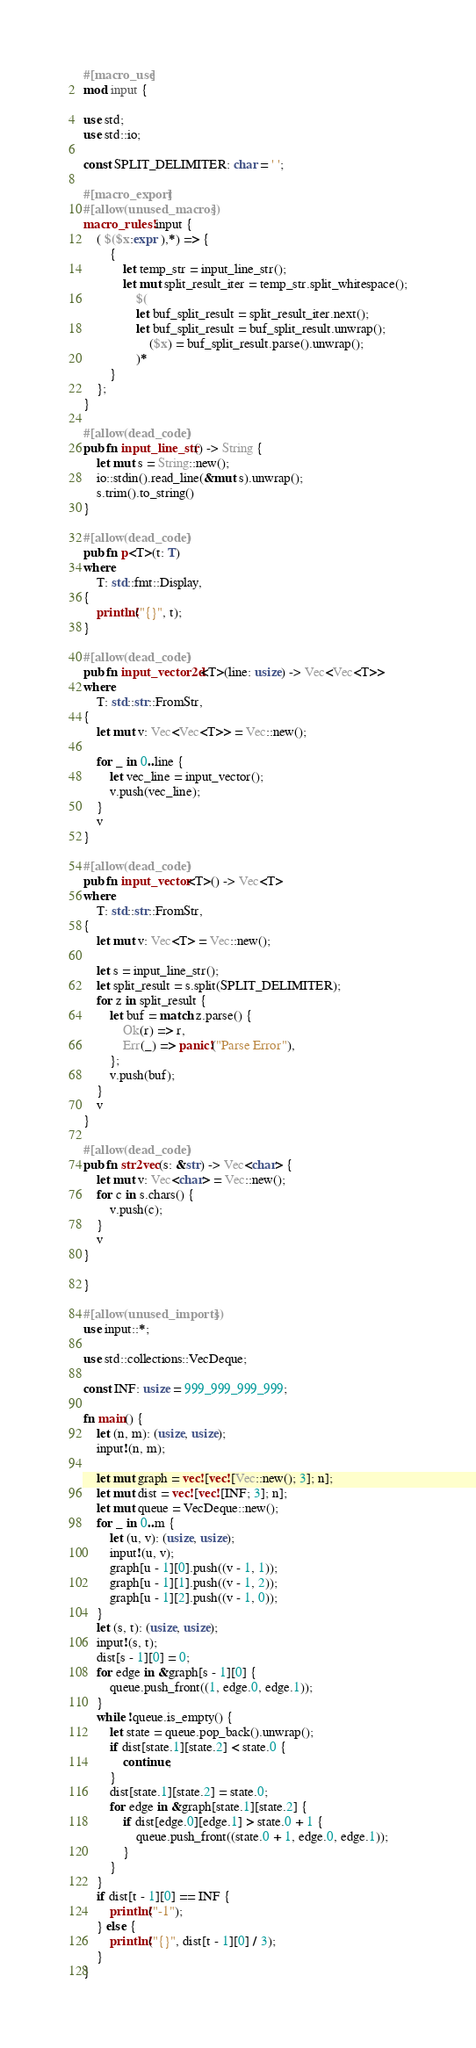<code> <loc_0><loc_0><loc_500><loc_500><_Rust_>#[macro_use]
mod input {

use std;
use std::io;

const SPLIT_DELIMITER: char = ' ';

#[macro_export]
#[allow(unused_macros)]
macro_rules! input {
    ( $($x:expr ),*) => {
        {
            let temp_str = input_line_str();
            let mut split_result_iter = temp_str.split_whitespace();
                $(
                let buf_split_result = split_result_iter.next();
                let buf_split_result = buf_split_result.unwrap();
                    ($x) = buf_split_result.parse().unwrap();
                )*
        }
    };
}

#[allow(dead_code)]
pub fn input_line_str() -> String {
    let mut s = String::new();
    io::stdin().read_line(&mut s).unwrap();
    s.trim().to_string()
}

#[allow(dead_code)]
pub fn p<T>(t: T)
where
    T: std::fmt::Display,
{
    println!("{}", t);
}

#[allow(dead_code)]
pub fn input_vector2d<T>(line: usize) -> Vec<Vec<T>>
where
    T: std::str::FromStr,
{
    let mut v: Vec<Vec<T>> = Vec::new();

    for _ in 0..line {
        let vec_line = input_vector();
        v.push(vec_line);
    }
    v
}

#[allow(dead_code)]
pub fn input_vector<T>() -> Vec<T>
where
    T: std::str::FromStr,
{
    let mut v: Vec<T> = Vec::new();

    let s = input_line_str();
    let split_result = s.split(SPLIT_DELIMITER);
    for z in split_result {
        let buf = match z.parse() {
            Ok(r) => r,
            Err(_) => panic!("Parse Error"),
        };
        v.push(buf);
    }
    v
}

#[allow(dead_code)]
pub fn str2vec(s: &str) -> Vec<char> {
    let mut v: Vec<char> = Vec::new();
    for c in s.chars() {
        v.push(c);
    }
    v
}

}

#[allow(unused_imports)]
use input::*;

use std::collections::VecDeque;

const INF: usize = 999_999_999_999;

fn main() {
    let (n, m): (usize, usize);
    input!(n, m);

    let mut graph = vec![vec![Vec::new(); 3]; n];
    let mut dist = vec![vec![INF; 3]; n];
    let mut queue = VecDeque::new();
    for _ in 0..m {
        let (u, v): (usize, usize);
        input!(u, v);
        graph[u - 1][0].push((v - 1, 1));
        graph[u - 1][1].push((v - 1, 2));
        graph[u - 1][2].push((v - 1, 0));
    }
    let (s, t): (usize, usize);
    input!(s, t);
    dist[s - 1][0] = 0;
    for edge in &graph[s - 1][0] {
        queue.push_front((1, edge.0, edge.1));
    }
    while !queue.is_empty() {
        let state = queue.pop_back().unwrap();
        if dist[state.1][state.2] < state.0 {
            continue;
        }
        dist[state.1][state.2] = state.0;
        for edge in &graph[state.1][state.2] {
            if dist[edge.0][edge.1] > state.0 + 1 {
                queue.push_front((state.0 + 1, edge.0, edge.1));
            }
        }
    }
    if dist[t - 1][0] == INF {
        println!("-1");
    } else {
        println!("{}", dist[t - 1][0] / 3);
    }
}</code> 